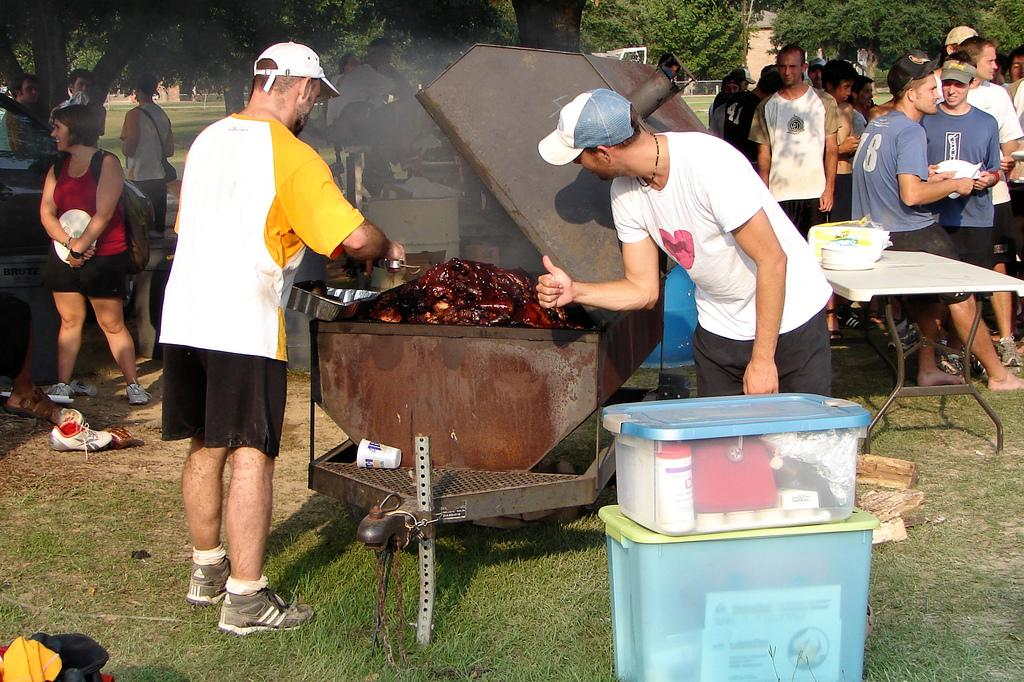<image>
Summarize the visual content of the image. A man barbecues a lot of meat outdoors while a man in a blue shirt with the number 78 talks to another man in a blue shirt. 